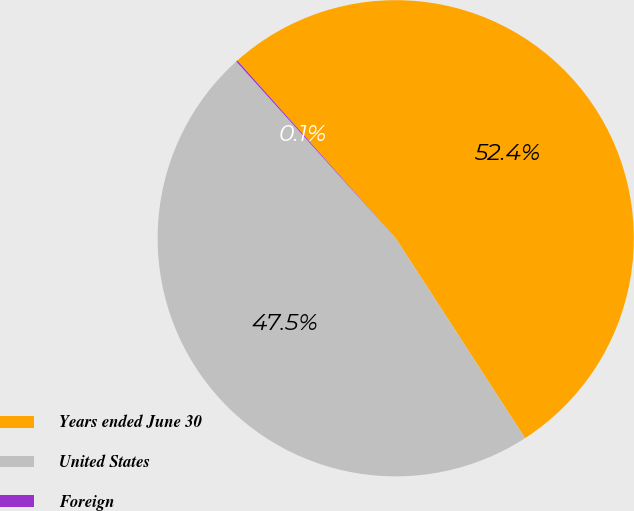Convert chart to OTSL. <chart><loc_0><loc_0><loc_500><loc_500><pie_chart><fcel>Years ended June 30<fcel>United States<fcel>Foreign<nl><fcel>52.44%<fcel>47.46%<fcel>0.1%<nl></chart> 